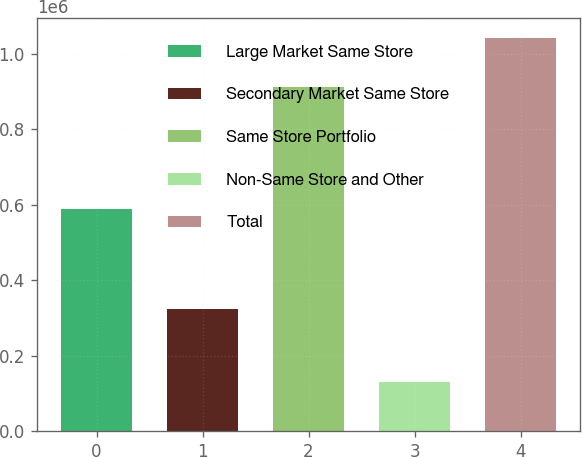<chart> <loc_0><loc_0><loc_500><loc_500><bar_chart><fcel>Large Market Same Store<fcel>Secondary Market Same Store<fcel>Same Store Portfolio<fcel>Non-Same Store and Other<fcel>Total<nl><fcel>587896<fcel>324771<fcel>912667<fcel>130112<fcel>1.04278e+06<nl></chart> 